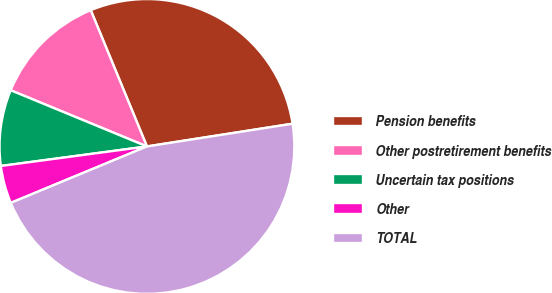<chart> <loc_0><loc_0><loc_500><loc_500><pie_chart><fcel>Pension benefits<fcel>Other postretirement benefits<fcel>Uncertain tax positions<fcel>Other<fcel>TOTAL<nl><fcel>28.76%<fcel>12.55%<fcel>8.34%<fcel>4.14%<fcel>46.21%<nl></chart> 